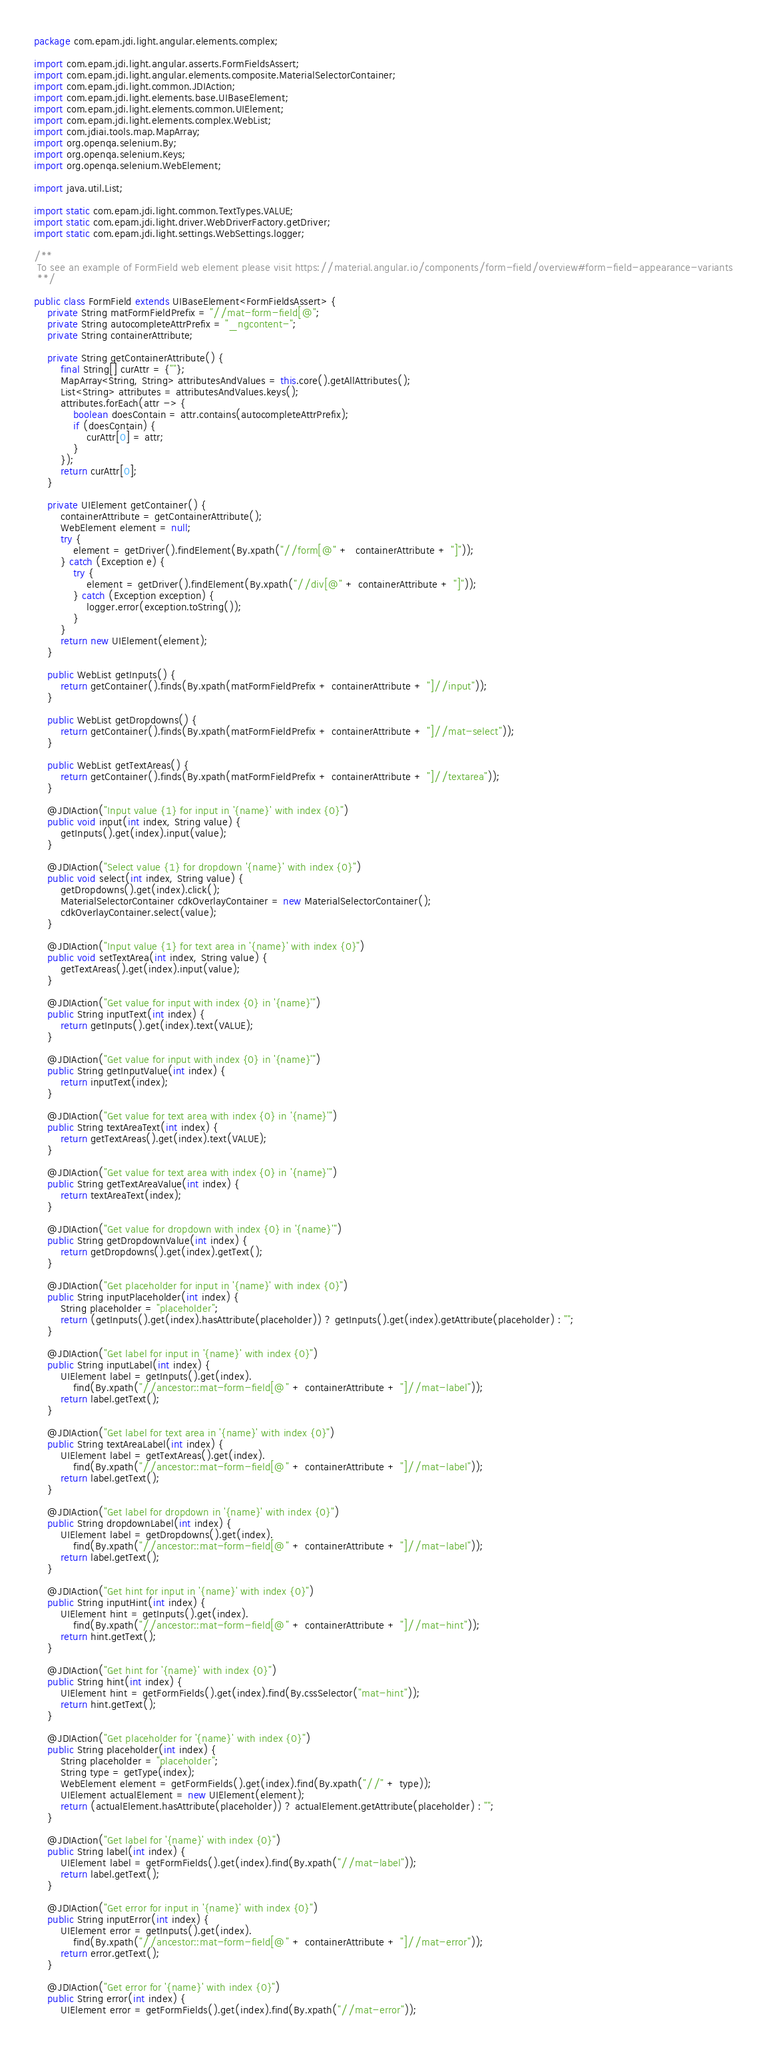Convert code to text. <code><loc_0><loc_0><loc_500><loc_500><_Java_>package com.epam.jdi.light.angular.elements.complex;

import com.epam.jdi.light.angular.asserts.FormFieldsAssert;
import com.epam.jdi.light.angular.elements.composite.MaterialSelectorContainer;
import com.epam.jdi.light.common.JDIAction;
import com.epam.jdi.light.elements.base.UIBaseElement;
import com.epam.jdi.light.elements.common.UIElement;
import com.epam.jdi.light.elements.complex.WebList;
import com.jdiai.tools.map.MapArray;
import org.openqa.selenium.By;
import org.openqa.selenium.Keys;
import org.openqa.selenium.WebElement;

import java.util.List;

import static com.epam.jdi.light.common.TextTypes.VALUE;
import static com.epam.jdi.light.driver.WebDriverFactory.getDriver;
import static com.epam.jdi.light.settings.WebSettings.logger;

/**
 To see an example of FormField web element please visit https://material.angular.io/components/form-field/overview#form-field-appearance-variants
 **/

public class FormField extends UIBaseElement<FormFieldsAssert> {
    private String matFormFieldPrefix = "//mat-form-field[@";
    private String autocompleteAttrPrefix = "_ngcontent-";
    private String containerAttribute;

    private String getContainerAttribute() {
        final String[] curAttr = {""};
        MapArray<String, String> attributesAndValues = this.core().getAllAttributes();
        List<String> attributes = attributesAndValues.keys();
        attributes.forEach(attr -> {
            boolean doesContain = attr.contains(autocompleteAttrPrefix);
            if (doesContain) {
                curAttr[0] = attr;
            }
        });
        return curAttr[0];
    }

    private UIElement getContainer() {
        containerAttribute = getContainerAttribute();
        WebElement element = null;
        try {
            element = getDriver().findElement(By.xpath("//form[@" +  containerAttribute + "]"));
        } catch (Exception e) {
            try {
                element = getDriver().findElement(By.xpath("//div[@" + containerAttribute + "]"));
            } catch (Exception exception) {
                logger.error(exception.toString());
            }
        }
        return new UIElement(element);
    }

    public WebList getInputs() {
        return getContainer().finds(By.xpath(matFormFieldPrefix + containerAttribute + "]//input"));
    }

    public WebList getDropdowns() {
        return getContainer().finds(By.xpath(matFormFieldPrefix + containerAttribute + "]//mat-select"));
    }

    public WebList getTextAreas() {
        return getContainer().finds(By.xpath(matFormFieldPrefix + containerAttribute + "]//textarea"));
    }

    @JDIAction("Input value {1} for input in '{name}' with index {0}")
    public void input(int index, String value) {
        getInputs().get(index).input(value);
    }

    @JDIAction("Select value {1} for dropdown '{name}' with index {0}")
    public void select(int index, String value) {
        getDropdowns().get(index).click();
        MaterialSelectorContainer cdkOverlayContainer = new MaterialSelectorContainer();
        cdkOverlayContainer.select(value);
    }

    @JDIAction("Input value {1} for text area in '{name}' with index {0}")
    public void setTextArea(int index, String value) {
        getTextAreas().get(index).input(value);
    }

    @JDIAction("Get value for input with index {0} in '{name}'")
    public String inputText(int index) {
        return getInputs().get(index).text(VALUE);
    }

    @JDIAction("Get value for input with index {0} in '{name}'")
    public String getInputValue(int index) {
        return inputText(index);
    }

    @JDIAction("Get value for text area with index {0} in '{name}'")
    public String textAreaText(int index) {
        return getTextAreas().get(index).text(VALUE);
    }

    @JDIAction("Get value for text area with index {0} in '{name}'")
    public String getTextAreaValue(int index) {
        return textAreaText(index);
    }

    @JDIAction("Get value for dropdown with index {0} in '{name}'")
    public String getDropdownValue(int index) {
        return getDropdowns().get(index).getText();
    }

    @JDIAction("Get placeholder for input in '{name}' with index {0}")
    public String inputPlaceholder(int index) {
        String placeholder = "placeholder";
        return (getInputs().get(index).hasAttribute(placeholder)) ? getInputs().get(index).getAttribute(placeholder) : "";
    }

    @JDIAction("Get label for input in '{name}' with index {0}")
    public String inputLabel(int index) {
        UIElement label = getInputs().get(index).
            find(By.xpath("//ancestor::mat-form-field[@" + containerAttribute + "]//mat-label"));
        return label.getText();
    }

    @JDIAction("Get label for text area in '{name}' with index {0}")
    public String textAreaLabel(int index) {
        UIElement label = getTextAreas().get(index).
            find(By.xpath("//ancestor::mat-form-field[@" + containerAttribute + "]//mat-label"));
        return label.getText();
    }

    @JDIAction("Get label for dropdown in '{name}' with index {0}")
    public String dropdownLabel(int index) {
        UIElement label = getDropdowns().get(index).
            find(By.xpath("//ancestor::mat-form-field[@" + containerAttribute + "]//mat-label"));
        return label.getText();
    }

    @JDIAction("Get hint for input in '{name}' with index {0}")
    public String inputHint(int index) {
        UIElement hint = getInputs().get(index).
            find(By.xpath("//ancestor::mat-form-field[@" + containerAttribute + "]//mat-hint"));
        return hint.getText();
    }

    @JDIAction("Get hint for '{name}' with index {0}")
    public String hint(int index) {
        UIElement hint = getFormFields().get(index).find(By.cssSelector("mat-hint"));
        return hint.getText();
    }

    @JDIAction("Get placeholder for '{name}' with index {0}")
    public String placeholder(int index) {
        String placeholder = "placeholder";
        String type = getType(index);
        WebElement element = getFormFields().get(index).find(By.xpath("//" + type));
        UIElement actualElement = new UIElement(element);
        return (actualElement.hasAttribute(placeholder)) ? actualElement.getAttribute(placeholder) : "";
    }

    @JDIAction("Get label for '{name}' with index {0}")
    public String label(int index) {
        UIElement label = getFormFields().get(index).find(By.xpath("//mat-label"));
        return label.getText();
    }

    @JDIAction("Get error for input in '{name}' with index {0}")
    public String inputError(int index) {
        UIElement error = getInputs().get(index).
            find(By.xpath("//ancestor::mat-form-field[@" + containerAttribute + "]//mat-error"));
        return error.getText();
    }

    @JDIAction("Get error for '{name}' with index {0}")
    public String error(int index) {
        UIElement error = getFormFields().get(index).find(By.xpath("//mat-error"));</code> 